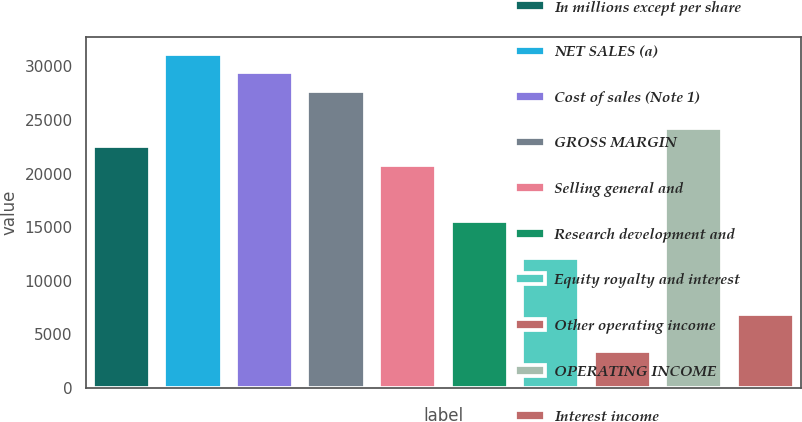Convert chart. <chart><loc_0><loc_0><loc_500><loc_500><bar_chart><fcel>In millions except per share<fcel>NET SALES (a)<fcel>Cost of sales (Note 1)<fcel>GROSS MARGIN<fcel>Selling general and<fcel>Research development and<fcel>Equity royalty and interest<fcel>Other operating income<fcel>OPERATING INCOME<fcel>Interest income<nl><fcel>22531.6<fcel>31194.2<fcel>29461.7<fcel>27729.2<fcel>20799<fcel>15601.4<fcel>12136.4<fcel>3473.73<fcel>24264.1<fcel>6938.79<nl></chart> 